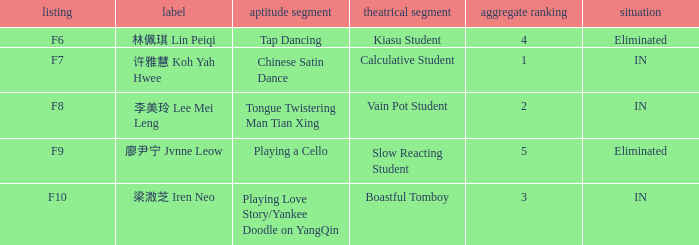What's the total number of overall rankings of 廖尹宁 jvnne leow's events that are eliminated? 1.0. 